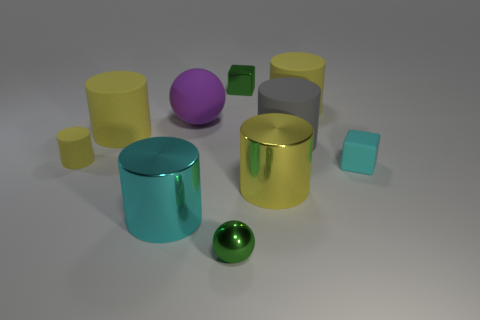Do the green metal thing that is behind the large cyan cylinder and the tiny green shiny object that is in front of the small cyan rubber thing have the same shape?
Keep it short and to the point. No. What material is the gray cylinder that is the same size as the matte sphere?
Your answer should be very brief. Rubber. What number of other things are there of the same material as the large purple thing
Ensure brevity in your answer.  5. What is the shape of the green object behind the small cube that is in front of the green shiny block?
Offer a very short reply. Cube. How many objects are green metal objects or big metal objects that are to the right of the big rubber ball?
Your response must be concise. 3. How many other objects are there of the same color as the small metal sphere?
Offer a terse response. 1. What number of green objects are either tiny objects or big metallic cylinders?
Give a very brief answer. 2. Is there a small cylinder right of the small cube to the right of the big metallic cylinder that is on the right side of the big cyan cylinder?
Your answer should be very brief. No. Is there any other thing that has the same size as the cyan metallic thing?
Offer a very short reply. Yes. Is the matte block the same color as the big ball?
Give a very brief answer. No. 